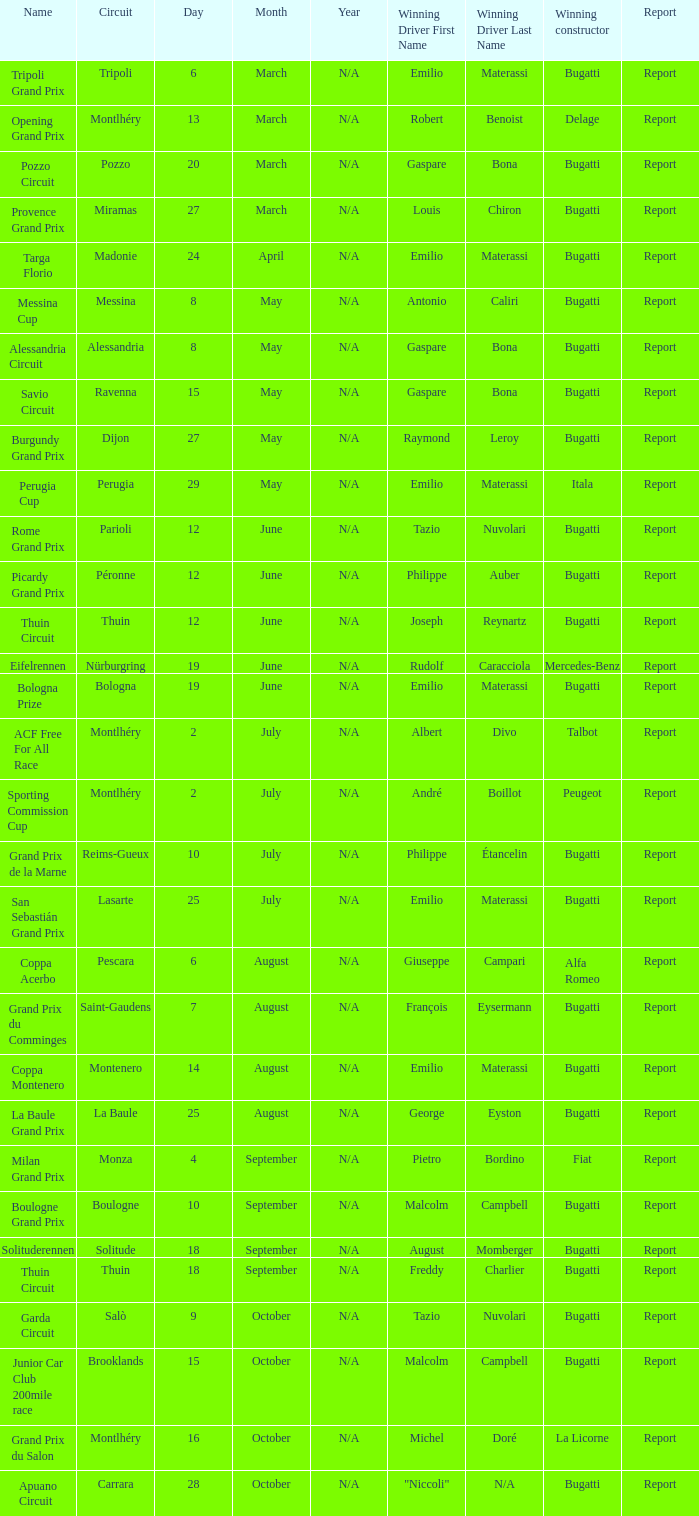Parse the table in full. {'header': ['Name', 'Circuit', 'Day', 'Month', 'Year', 'Winning Driver First Name', 'Winning Driver Last Name', 'Winning constructor', 'Report'], 'rows': [['Tripoli Grand Prix', 'Tripoli', '6', 'March', 'N/A', 'Emilio', 'Materassi', 'Bugatti', 'Report'], ['Opening Grand Prix', 'Montlhéry', '13', 'March', 'N/A', 'Robert', 'Benoist', 'Delage', 'Report'], ['Pozzo Circuit', 'Pozzo', '20', 'March', 'N/A', 'Gaspare', 'Bona', 'Bugatti', 'Report'], ['Provence Grand Prix', 'Miramas', '27', 'March', 'N/A', 'Louis', 'Chiron', 'Bugatti', 'Report'], ['Targa Florio', 'Madonie', '24', 'April', 'N/A', 'Emilio', 'Materassi', 'Bugatti', 'Report'], ['Messina Cup', 'Messina', '8', 'May', 'N/A', 'Antonio', 'Caliri', 'Bugatti', 'Report'], ['Alessandria Circuit', 'Alessandria', '8', 'May', 'N/A', 'Gaspare', 'Bona', 'Bugatti', 'Report'], ['Savio Circuit', 'Ravenna', '15', 'May', 'N/A', 'Gaspare', 'Bona', 'Bugatti', 'Report'], ['Burgundy Grand Prix', 'Dijon', '27', 'May', 'N/A', 'Raymond', 'Leroy', 'Bugatti', 'Report'], ['Perugia Cup', 'Perugia', '29', 'May', 'N/A', 'Emilio', 'Materassi', 'Itala', 'Report'], ['Rome Grand Prix', 'Parioli', '12', 'June', 'N/A', 'Tazio', 'Nuvolari', 'Bugatti', 'Report'], ['Picardy Grand Prix', 'Péronne', '12', 'June', 'N/A', 'Philippe', 'Auber', 'Bugatti', 'Report'], ['Thuin Circuit', 'Thuin', '12', 'June', 'N/A', 'Joseph', 'Reynartz', 'Bugatti', 'Report'], ['Eifelrennen', 'Nürburgring', '19', 'June', 'N/A', 'Rudolf', 'Caracciola', 'Mercedes-Benz', 'Report'], ['Bologna Prize', 'Bologna', '19', 'June', 'N/A', 'Emilio', 'Materassi', 'Bugatti', 'Report'], ['ACF Free For All Race', 'Montlhéry', '2', 'July', 'N/A', 'Albert', 'Divo', 'Talbot', 'Report'], ['Sporting Commission Cup', 'Montlhéry', '2', 'July', 'N/A', 'André', 'Boillot', 'Peugeot', 'Report'], ['Grand Prix de la Marne', 'Reims-Gueux', '10', 'July', 'N/A', 'Philippe', 'Étancelin', 'Bugatti', 'Report'], ['San Sebastián Grand Prix', 'Lasarte', '25', 'July', 'N/A', 'Emilio', 'Materassi', 'Bugatti', 'Report'], ['Coppa Acerbo', 'Pescara', '6', 'August', 'N/A', 'Giuseppe', 'Campari', 'Alfa Romeo', 'Report'], ['Grand Prix du Comminges', 'Saint-Gaudens', '7', 'August', 'N/A', 'François', 'Eysermann', 'Bugatti', 'Report'], ['Coppa Montenero', 'Montenero', '14', 'August', 'N/A', 'Emilio', 'Materassi', 'Bugatti', 'Report'], ['La Baule Grand Prix', 'La Baule', '25', 'August', 'N/A', 'George', 'Eyston', 'Bugatti', 'Report'], ['Milan Grand Prix', 'Monza', '4', 'September', 'N/A', 'Pietro', 'Bordino', 'Fiat', 'Report'], ['Boulogne Grand Prix', 'Boulogne', '10', 'September', 'N/A', 'Malcolm', 'Campbell', 'Bugatti', 'Report'], ['Solituderennen', 'Solitude', '18', 'September', 'N/A', 'August', 'Momberger', 'Bugatti', 'Report'], ['Thuin Circuit', 'Thuin', '18', 'September', 'N/A', 'Freddy', 'Charlier', 'Bugatti', 'Report'], ['Garda Circuit', 'Salò', '9', 'October', 'N/A', 'Tazio', 'Nuvolari', 'Bugatti', 'Report'], ['Junior Car Club 200mile race', 'Brooklands', '15', 'October', 'N/A', 'Malcolm', 'Campbell', 'Bugatti', 'Report'], ['Grand Prix du Salon', 'Montlhéry', '16', 'October', 'N/A', 'Michel', 'Doré', 'La Licorne', 'Report'], ['Apuano Circuit', 'Carrara', '28', 'October', 'N/A', '"Niccoli"', 'N/A', 'Bugatti', 'Report']]} Which circuit did françois eysermann win ? Saint-Gaudens. 